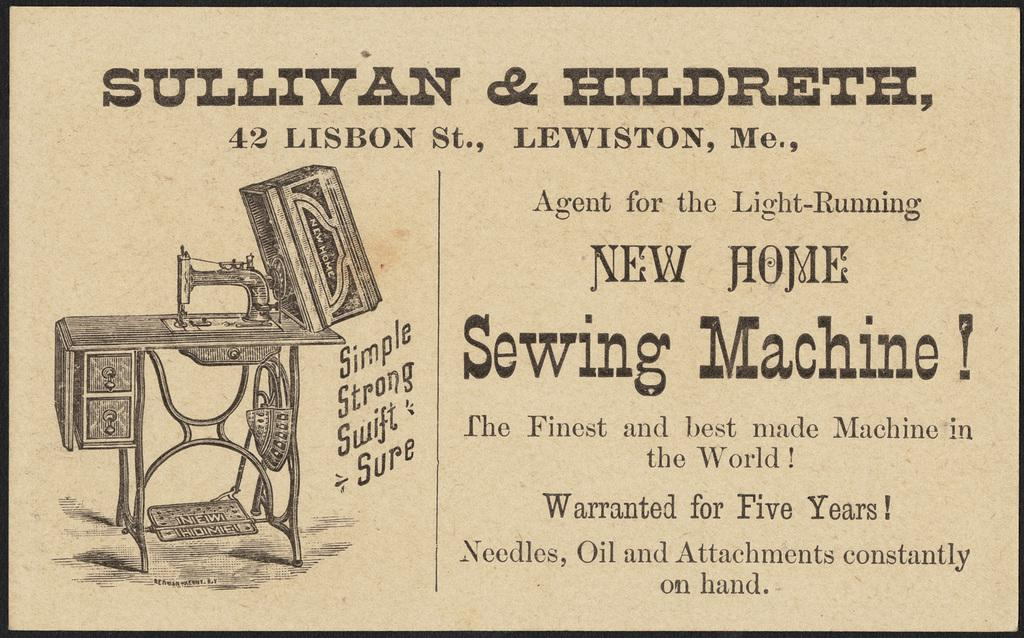What is present in the image that has a picture on it? There is a paper in the image that has a picture of a sewing machine. What is the subject of the picture on the paper? The picture on the paper is of a sewing machine. Is there any text on the paper? Yes, there is writing on the paper. What is the aftermath of the giants' battle in the image? There is no mention of giants or a battle in the image; it only features a paper with a picture of a sewing machine and writing. 